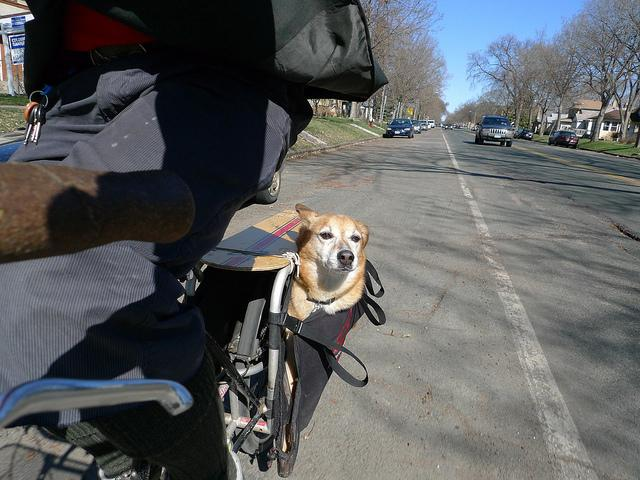How is the dog probably traveling? bicycle 